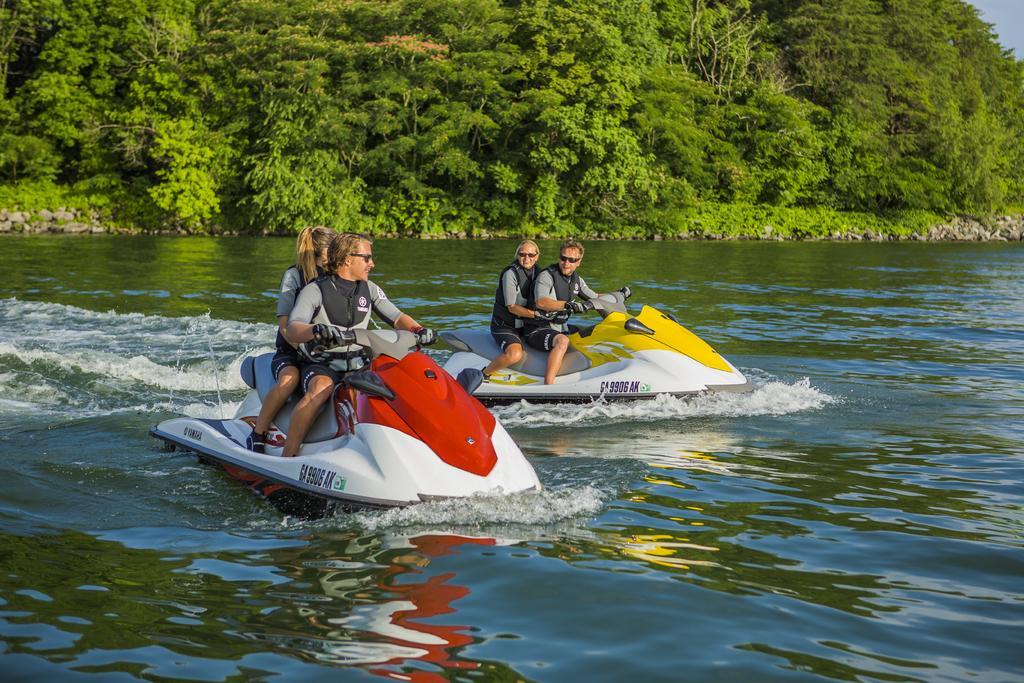Please provide a concise description of this image. This image is taken outdoors. In the background there are many trees and plants with green leaves, stems and branches. There are a few stones on the ground. At the top right of the image there is the sky. At the bottom of the image there is a river with water. In the middle of the image two men and two women are sitting on the streamer boat and riding on the river. 